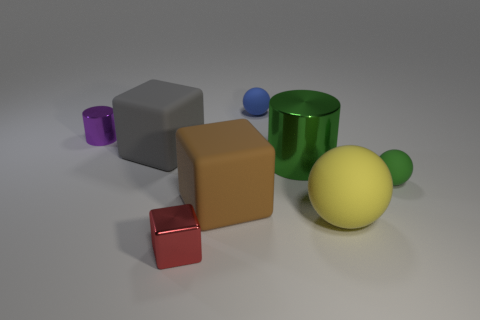What is the shape of the object that is both on the right side of the big brown thing and to the left of the large cylinder?
Offer a very short reply. Sphere. What number of other objects are there of the same shape as the large yellow thing?
Give a very brief answer. 2. What is the shape of the large rubber object behind the metallic cylinder in front of the cylinder to the left of the gray rubber thing?
Offer a very short reply. Cube. What number of things are tiny green rubber things or tiny shiny objects left of the gray rubber cube?
Provide a short and direct response. 2. There is a shiny thing to the right of the red thing; is its shape the same as the tiny shiny object behind the big brown cube?
Make the answer very short. Yes. What number of things are either tiny cyan rubber blocks or large blocks?
Make the answer very short. 2. Is there a tiny thing?
Keep it short and to the point. Yes. Is the small ball behind the green matte object made of the same material as the large yellow thing?
Ensure brevity in your answer.  Yes. Is there a matte thing that has the same shape as the red metal object?
Your response must be concise. Yes. Are there an equal number of large brown things that are behind the large gray block and shiny cylinders?
Ensure brevity in your answer.  No. 